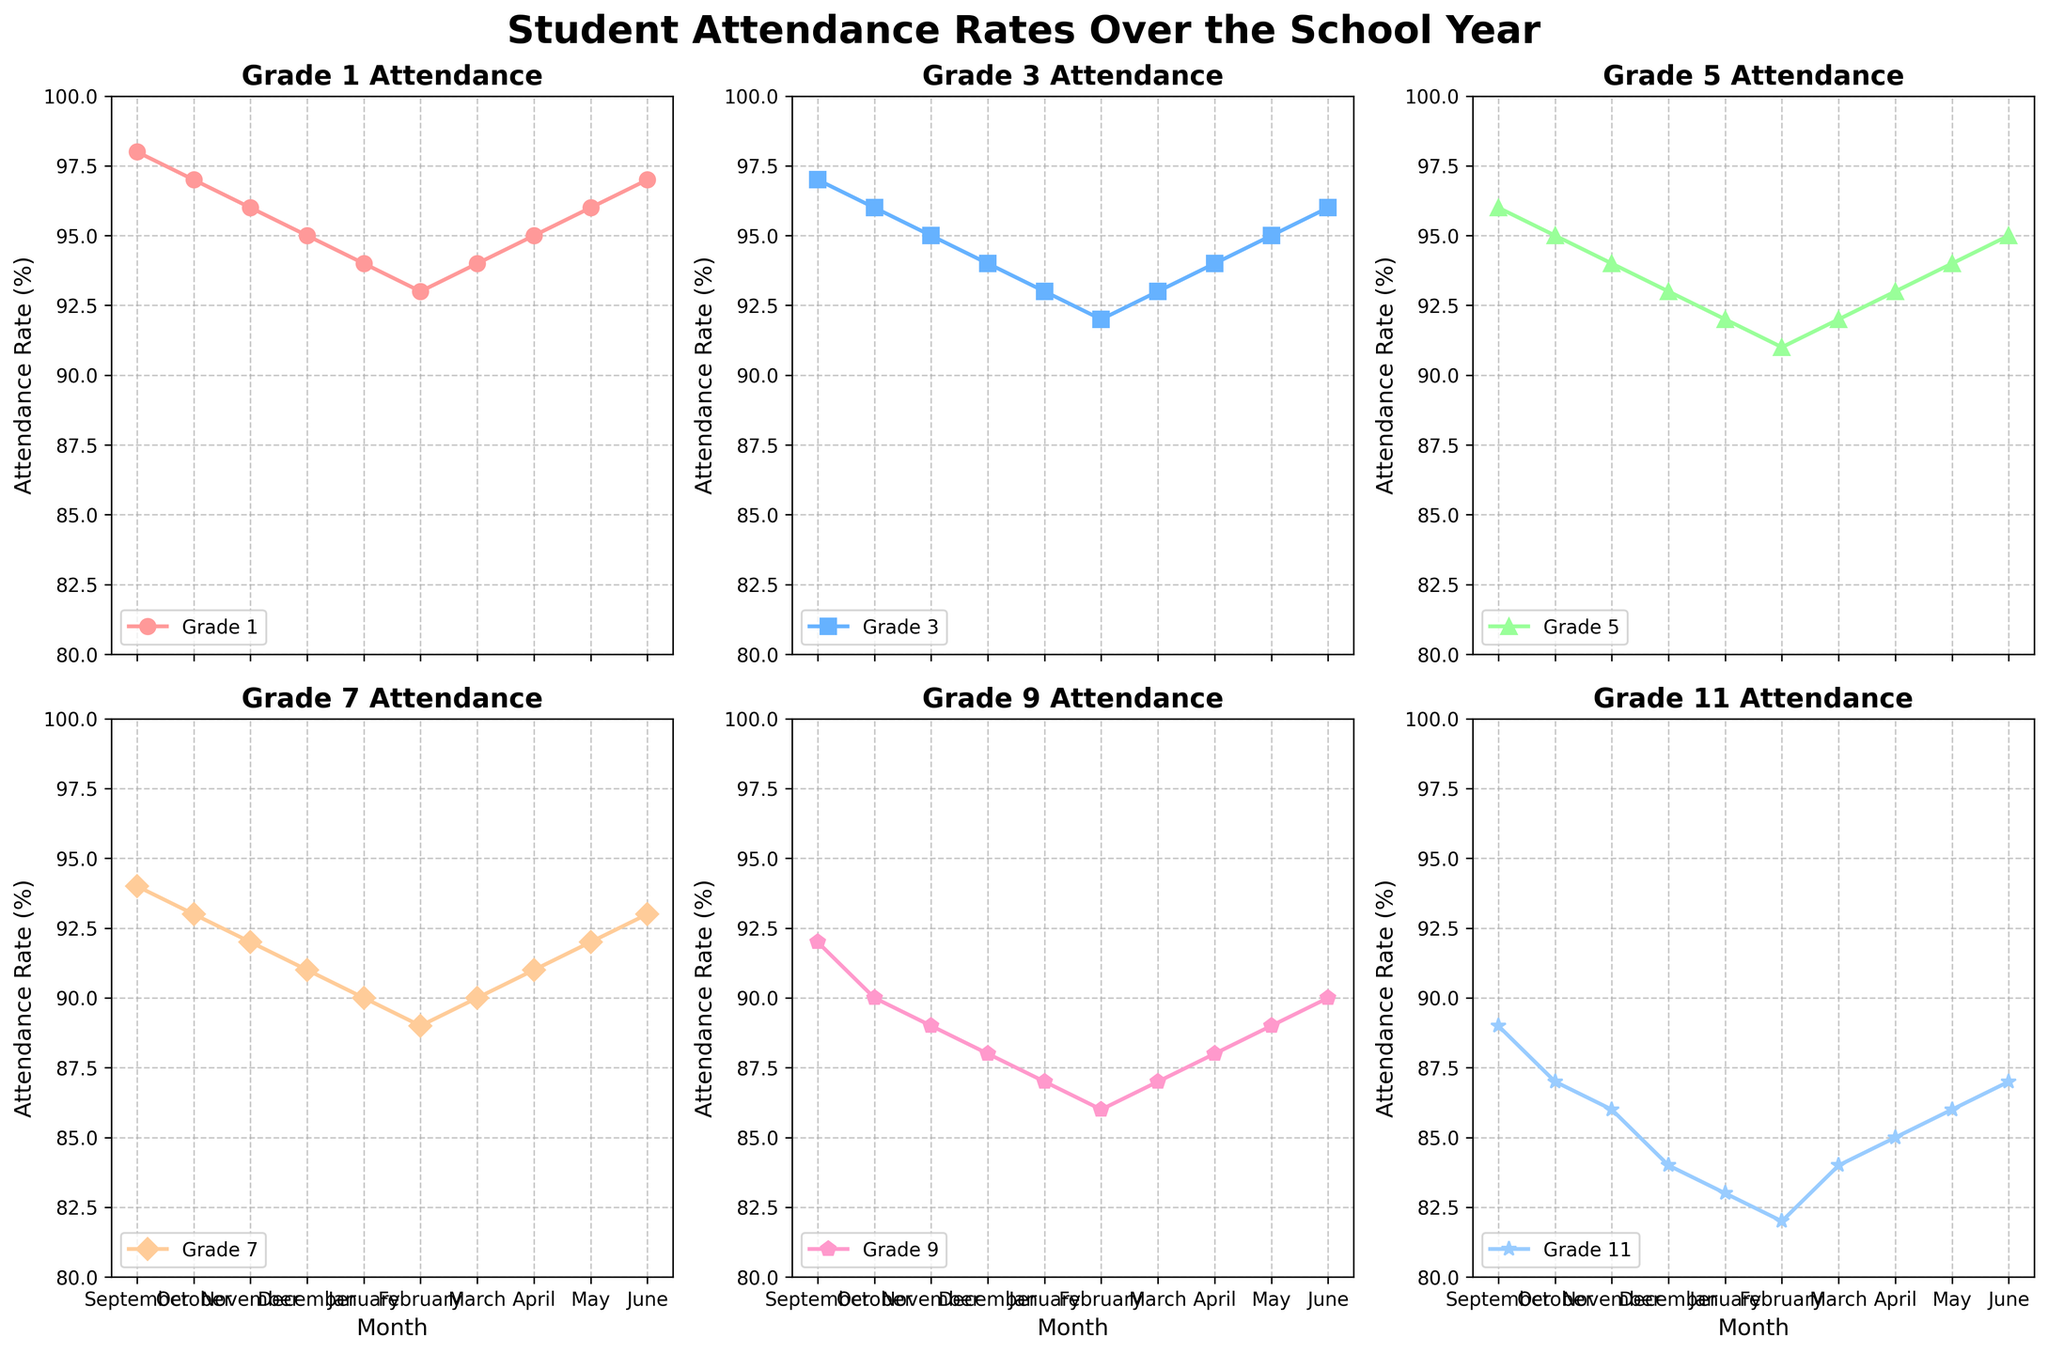What's the title of the figure? The title is positioned at the top of the figure and is indicated in a bold, larger font. It provides an overview of what the figure is about.
Answer: Student Attendance Rates Over the School Year How many grades are represented in this figure? Each subplot is dedicated to a specific grade. By counting the number of subplots, we can determine the number of grades represented.
Answer: 6 Which grade has the lowest attendance rate in January? By looking at the data points for January in each subplot, we can compare the attendance rates and identify the lowest one. Grade 11 has the lowest attendance rate of 83%.
Answer: Grade 11 Which grade shows the most variability in attendance rates throughout the year? Variability can be assessed by observing the range of attendance rates for each grade across the months. Grade 1 and Grade 11 cover the most fluctuation, but Grade 11 from 83% to 89% (6 percentage points) is the highest.
Answer: Grade 11 What is the attendance trend for Grade 5 from September to June? By following the line in the Grade 5 subplot, we can observe whether the attendance rate is increasing, decreasing, or fluctuating over the months.
Answer: Decreasing trend Which month has the highest attendance for Grade 3? By identifying the highest data point in the Grade 3 subplot, we can determine the month with the highest attendance rate.
Answer: September In which month do Grade 7 and Grade 9 have the same attendance rate? By analyzing the attendance rates for both Grade 7 and Grade 9 across all months, we can find the month where they intersect. Both rates are 90% in January.
Answer: January What is the average attendance rate for Grade 1 across the school year? To find the average, sum up the attendance rates for all months in the Grade 1 subplot and divide by the number of months (10). The calculation gives (98+97+96+95+94+93+94+95+96+97)/10 = 95.5.
Answer: 95.5 How does the peak attendance rate for Grade 11 compare to the peak attendance rate for Grade 1? By identifying the highest data points in both subplots, we see Grade 11 peaks at 89% whereas Grade 1 peaks at 98%. Comparing these values shows a difference where Grade 1 is higher by 9 percentage points.
Answer: Grade 1 is higher by 9% During which month does the overall attendance rate begin to rise again after a continuous decline for multiple grades? Observation of the visual trends across subplots helps identify when most grades' attendance rates shift from decreasing to increasing. After continuous decline, many grades start to rise again around March and April.
Answer: March or April 